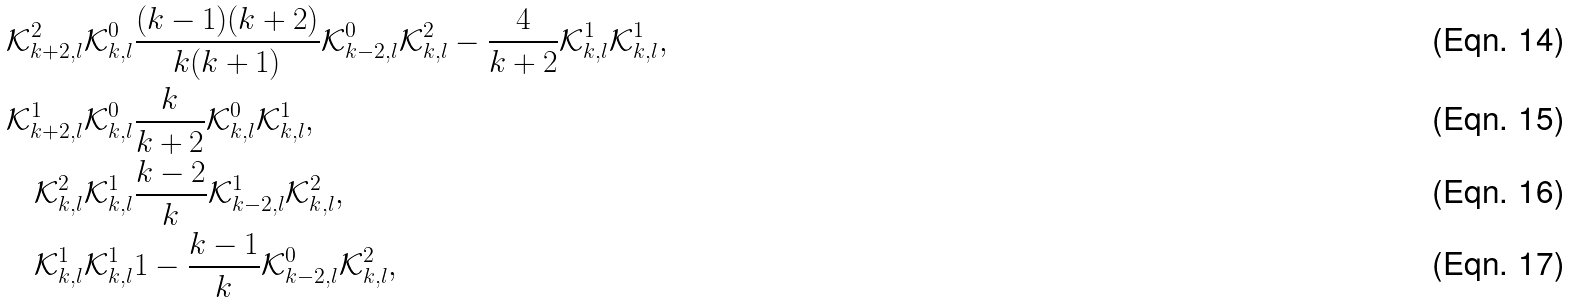Convert formula to latex. <formula><loc_0><loc_0><loc_500><loc_500>\mathcal { K } ^ { 2 } _ { k + 2 , l } \mathcal { K } ^ { 0 } _ { k , l } & \frac { ( k - 1 ) ( k + 2 ) } { k ( k + 1 ) } \mathcal { K } ^ { 0 } _ { k - 2 , l } \mathcal { K } ^ { 2 } _ { k , l } - \frac { 4 } { k + 2 } \mathcal { K } ^ { 1 } _ { k , l } \mathcal { K } ^ { 1 } _ { k , l } , \\ \mathcal { K } ^ { 1 } _ { k + 2 , l } \mathcal { K } ^ { 0 } _ { k , l } & \frac { k } { k + 2 } \mathcal { K } ^ { 0 } _ { k , l } \mathcal { K } ^ { 1 } _ { k , l } , \\ \mathcal { K } ^ { 2 } _ { k , l } \mathcal { K } ^ { 1 } _ { k , l } & \frac { k - 2 } { k } \mathcal { K } ^ { 1 } _ { k - 2 , l } \mathcal { K } ^ { 2 } _ { k , l } , \\ \mathcal { K } ^ { 1 } _ { k , l } \mathcal { K } ^ { 1 } _ { k , l } & 1 - \frac { k - 1 } { k } \mathcal { K } ^ { 0 } _ { k - 2 , l } \mathcal { K } ^ { 2 } _ { k , l } ,</formula> 